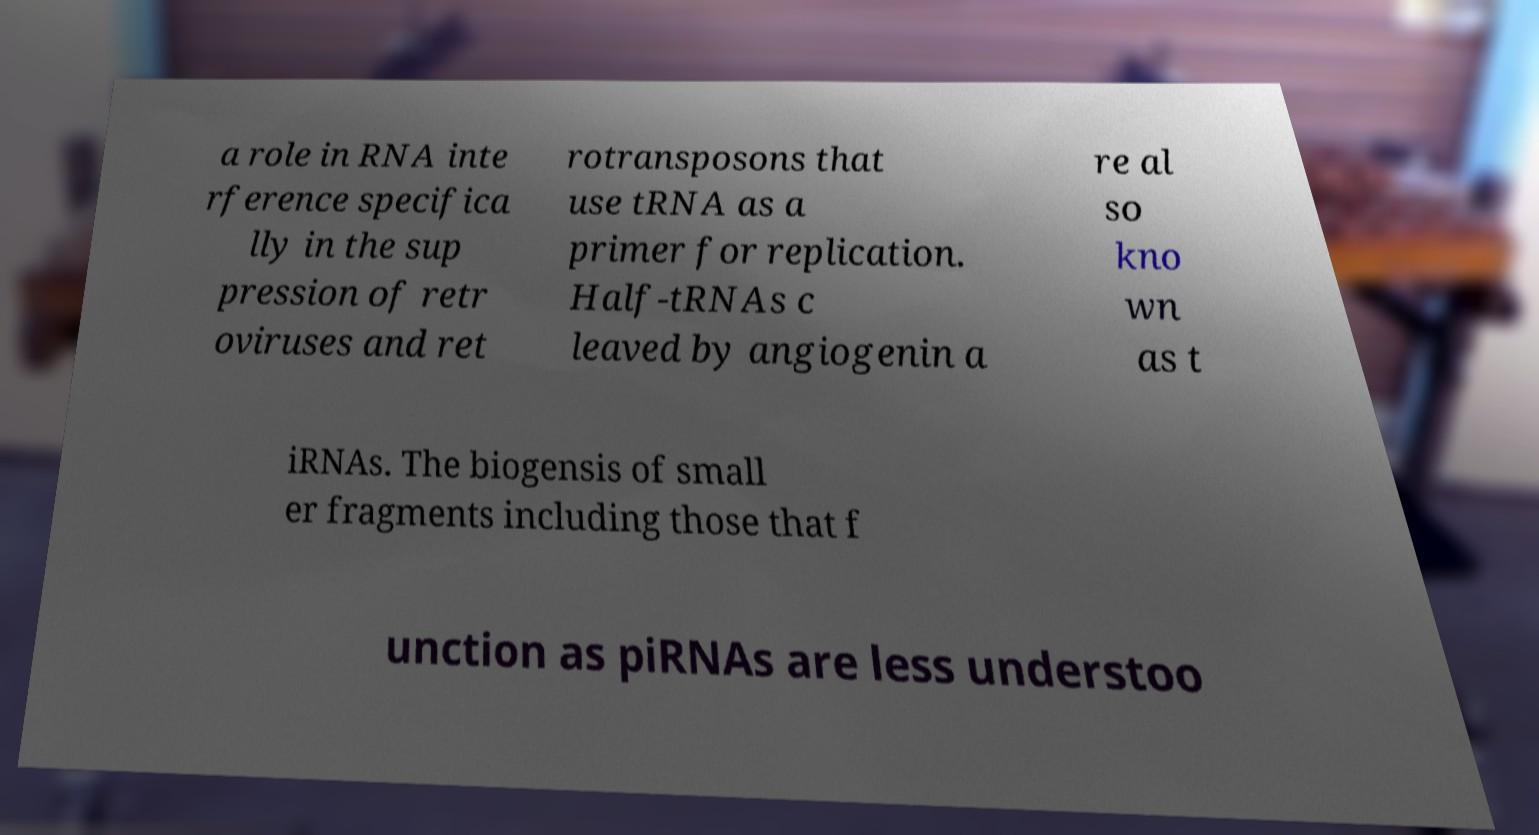Can you read and provide the text displayed in the image?This photo seems to have some interesting text. Can you extract and type it out for me? a role in RNA inte rference specifica lly in the sup pression of retr oviruses and ret rotransposons that use tRNA as a primer for replication. Half-tRNAs c leaved by angiogenin a re al so kno wn as t iRNAs. The biogensis of small er fragments including those that f unction as piRNAs are less understoo 